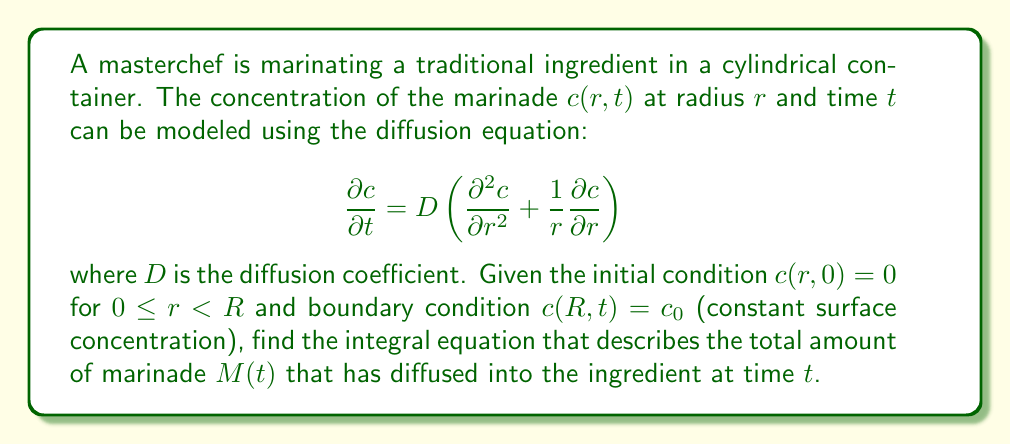What is the answer to this math problem? To solve this problem, we'll follow these steps:

1) The total amount of marinade $M(t)$ that has diffused into the ingredient at time $t$ is given by the integral:

   $$M(t) = 2\pi L \int_0^R c(r,t)r\,dr$$

   where $L$ is the length of the cylindrical ingredient.

2) The solution to the diffusion equation with the given initial and boundary conditions is:

   $$c(r,t) = c_0\left(1 - \frac{2}{R}\sum_{n=1}^{\infty}\frac{J_0(α_n r/R)}{α_n J_1(α_n)}\exp\left(-Dα_n^2t/R^2\right)\right)$$

   where $J_0$ and $J_1$ are Bessel functions of the first kind of order 0 and 1, respectively, and $α_n$ are the positive roots of $J_0(α_n) = 0$.

3) Substituting this solution into the integral for $M(t)$:

   $$M(t) = 2\pi L c_0 \int_0^R \left(1 - \frac{2}{R}\sum_{n=1}^{\infty}\frac{J_0(α_n r/R)}{α_n J_1(α_n)}\exp\left(-Dα_n^2t/R^2\right)\right)r\,dr$$

4) Simplifying and integrating:

   $$M(t) = \pi R^2 L c_0 \left(1 - 4\sum_{n=1}^{\infty}\frac{\exp(-Dα_n^2t/R^2)}{α_n^2}\right)$$

5) This can be written as an integral equation:

   $$M(t) = \pi R^2 L c_0 \left(1 - 4\int_0^{\infty}\frac{\exp(-Dx^2t/R^2)}{x^2}dN(x)\right)$$

   where $N(x)$ is the counting function for the positive roots of $J_0(x) = 0$.

This integral equation describes the total amount of marinade that has diffused into the ingredient at time $t$.
Answer: $$M(t) = \pi R^2 L c_0 \left(1 - 4\int_0^{\infty}\frac{\exp(-Dx^2t/R^2)}{x^2}dN(x)\right)$$ 